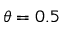Convert formula to latex. <formula><loc_0><loc_0><loc_500><loc_500>\theta = 0 . 5</formula> 